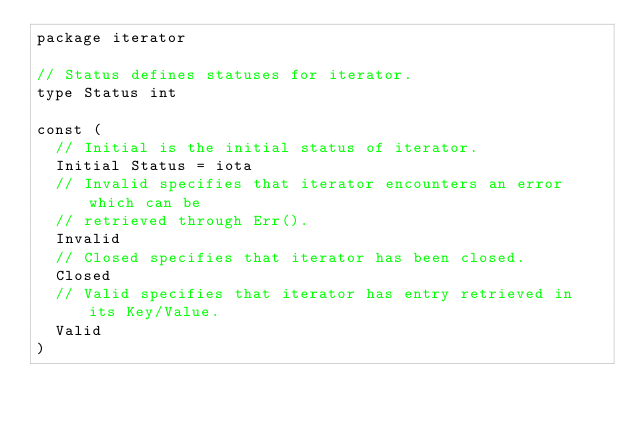<code> <loc_0><loc_0><loc_500><loc_500><_Go_>package iterator

// Status defines statuses for iterator.
type Status int

const (
	// Initial is the initial status of iterator.
	Initial Status = iota
	// Invalid specifies that iterator encounters an error which can be
	// retrieved through Err().
	Invalid
	// Closed specifies that iterator has been closed.
	Closed
	// Valid specifies that iterator has entry retrieved in its Key/Value.
	Valid
)
</code> 